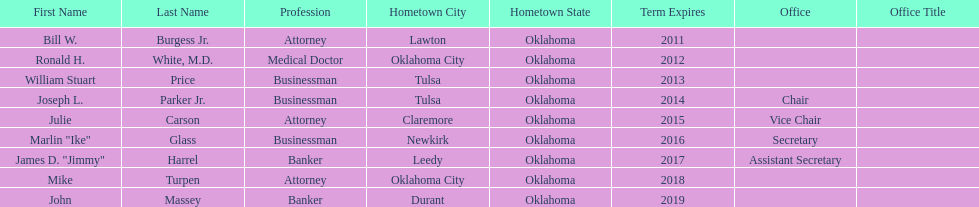How many of the current state regents will be in office until at least 2016? 4. 